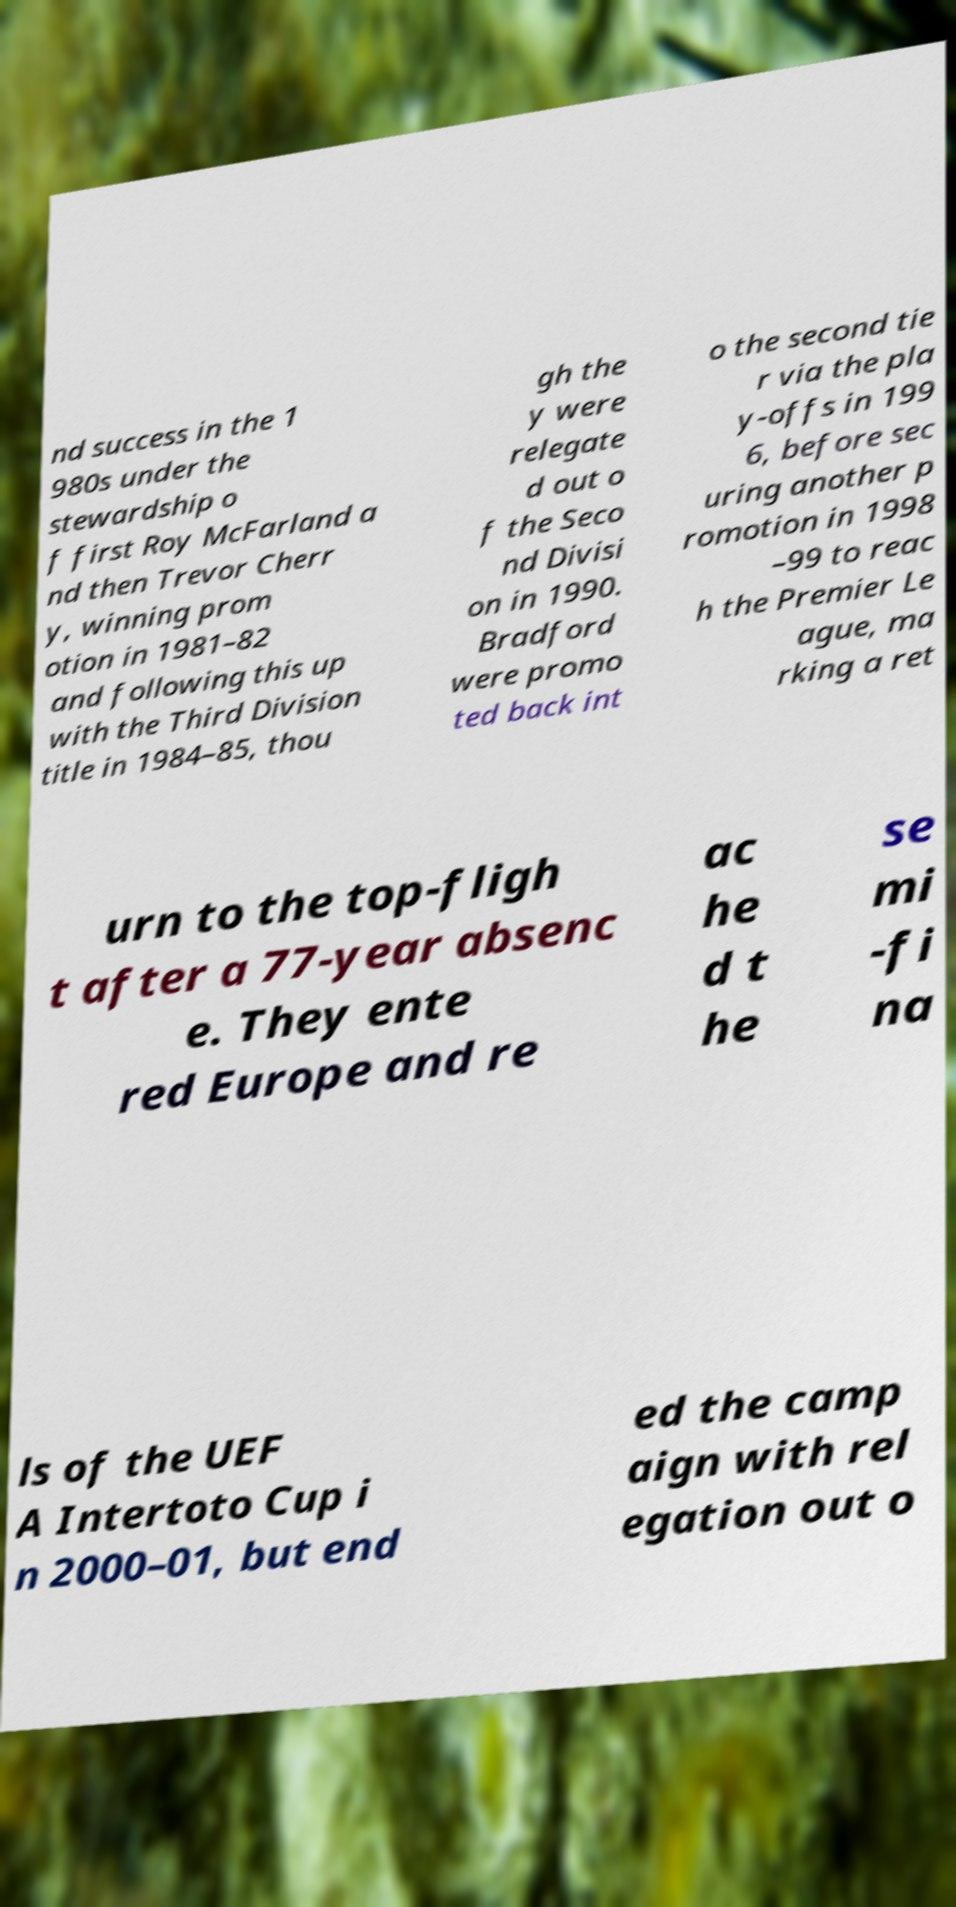Could you extract and type out the text from this image? nd success in the 1 980s under the stewardship o f first Roy McFarland a nd then Trevor Cherr y, winning prom otion in 1981–82 and following this up with the Third Division title in 1984–85, thou gh the y were relegate d out o f the Seco nd Divisi on in 1990. Bradford were promo ted back int o the second tie r via the pla y-offs in 199 6, before sec uring another p romotion in 1998 –99 to reac h the Premier Le ague, ma rking a ret urn to the top-fligh t after a 77-year absenc e. They ente red Europe and re ac he d t he se mi -fi na ls of the UEF A Intertoto Cup i n 2000–01, but end ed the camp aign with rel egation out o 